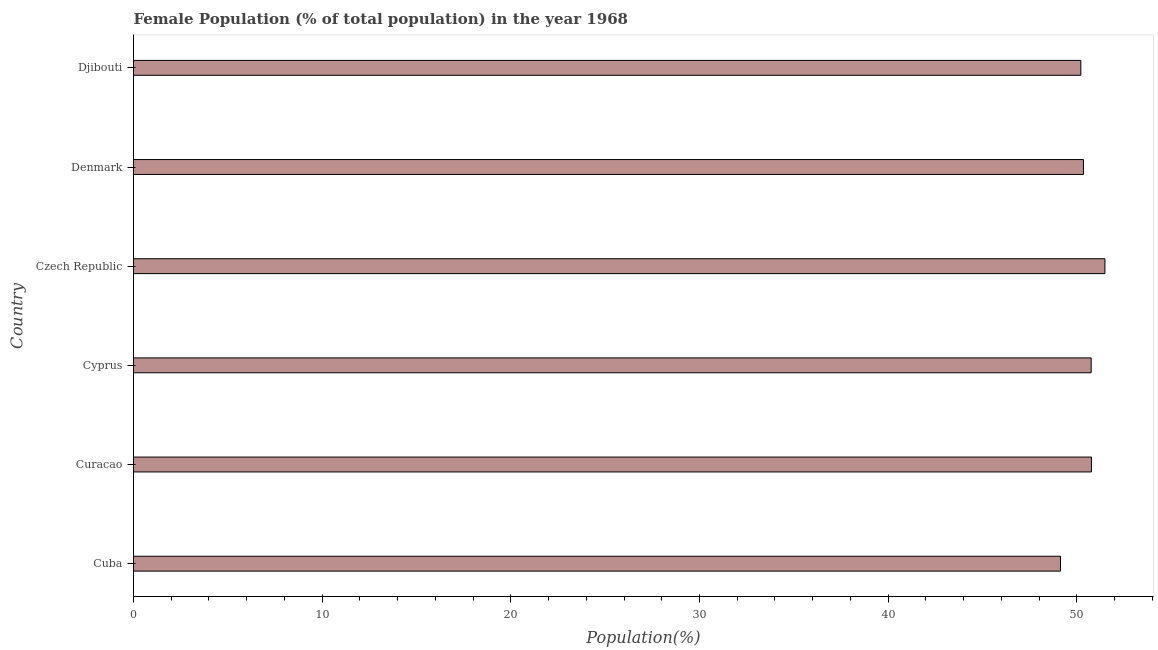Does the graph contain any zero values?
Offer a very short reply. No. What is the title of the graph?
Make the answer very short. Female Population (% of total population) in the year 1968. What is the label or title of the X-axis?
Provide a succinct answer. Population(%). What is the label or title of the Y-axis?
Offer a very short reply. Country. What is the female population in Cyprus?
Offer a terse response. 50.76. Across all countries, what is the maximum female population?
Your answer should be very brief. 51.49. Across all countries, what is the minimum female population?
Offer a very short reply. 49.13. In which country was the female population maximum?
Give a very brief answer. Czech Republic. In which country was the female population minimum?
Give a very brief answer. Cuba. What is the sum of the female population?
Give a very brief answer. 302.71. What is the difference between the female population in Czech Republic and Djibouti?
Provide a short and direct response. 1.28. What is the average female population per country?
Your answer should be very brief. 50.45. What is the median female population?
Ensure brevity in your answer.  50.55. What is the ratio of the female population in Cuba to that in Czech Republic?
Keep it short and to the point. 0.95. Is the female population in Cuba less than that in Curacao?
Offer a terse response. Yes. Is the difference between the female population in Curacao and Czech Republic greater than the difference between any two countries?
Your response must be concise. No. What is the difference between the highest and the second highest female population?
Your answer should be very brief. 0.72. What is the difference between the highest and the lowest female population?
Your answer should be compact. 2.36. How many bars are there?
Your answer should be compact. 6. What is the difference between two consecutive major ticks on the X-axis?
Your answer should be compact. 10. What is the Population(%) of Cuba?
Give a very brief answer. 49.13. What is the Population(%) of Curacao?
Offer a very short reply. 50.77. What is the Population(%) in Cyprus?
Provide a short and direct response. 50.76. What is the Population(%) of Czech Republic?
Your answer should be compact. 51.49. What is the Population(%) in Denmark?
Provide a succinct answer. 50.35. What is the Population(%) of Djibouti?
Give a very brief answer. 50.21. What is the difference between the Population(%) in Cuba and Curacao?
Your response must be concise. -1.64. What is the difference between the Population(%) in Cuba and Cyprus?
Provide a short and direct response. -1.63. What is the difference between the Population(%) in Cuba and Czech Republic?
Your answer should be very brief. -2.36. What is the difference between the Population(%) in Cuba and Denmark?
Your response must be concise. -1.22. What is the difference between the Population(%) in Cuba and Djibouti?
Your answer should be very brief. -1.08. What is the difference between the Population(%) in Curacao and Cyprus?
Your answer should be very brief. 0.01. What is the difference between the Population(%) in Curacao and Czech Republic?
Ensure brevity in your answer.  -0.72. What is the difference between the Population(%) in Curacao and Denmark?
Your response must be concise. 0.42. What is the difference between the Population(%) in Curacao and Djibouti?
Your answer should be compact. 0.56. What is the difference between the Population(%) in Cyprus and Czech Republic?
Provide a short and direct response. -0.73. What is the difference between the Population(%) in Cyprus and Denmark?
Offer a terse response. 0.41. What is the difference between the Population(%) in Cyprus and Djibouti?
Keep it short and to the point. 0.55. What is the difference between the Population(%) in Czech Republic and Denmark?
Provide a short and direct response. 1.14. What is the difference between the Population(%) in Czech Republic and Djibouti?
Your response must be concise. 1.28. What is the difference between the Population(%) in Denmark and Djibouti?
Provide a succinct answer. 0.14. What is the ratio of the Population(%) in Cuba to that in Czech Republic?
Provide a succinct answer. 0.95. What is the ratio of the Population(%) in Curacao to that in Denmark?
Offer a terse response. 1.01. What is the ratio of the Population(%) in Cyprus to that in Czech Republic?
Ensure brevity in your answer.  0.99. What is the ratio of the Population(%) in Cyprus to that in Denmark?
Give a very brief answer. 1.01. What is the ratio of the Population(%) in Cyprus to that in Djibouti?
Ensure brevity in your answer.  1.01. What is the ratio of the Population(%) in Czech Republic to that in Denmark?
Your answer should be compact. 1.02. What is the ratio of the Population(%) in Czech Republic to that in Djibouti?
Your answer should be compact. 1.02. 